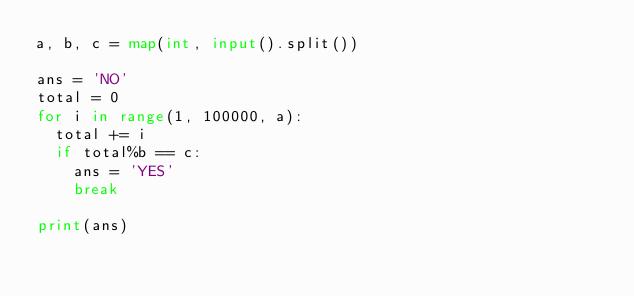Convert code to text. <code><loc_0><loc_0><loc_500><loc_500><_Python_>a, b, c = map(int, input().split())

ans = 'NO'
total = 0
for i in range(1, 100000, a):
  total += i
  if total%b == c:
    ans = 'YES'
    break
  
print(ans)
</code> 